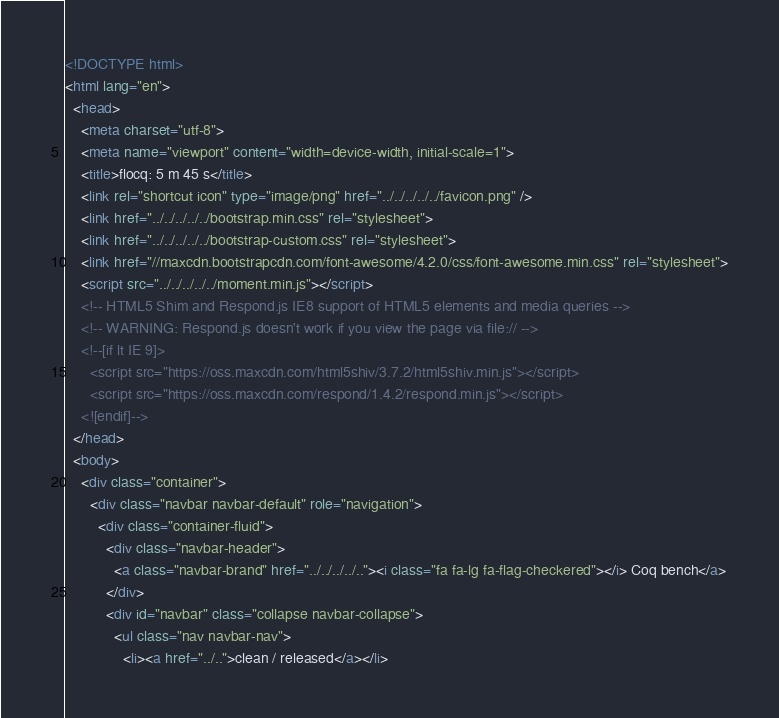<code> <loc_0><loc_0><loc_500><loc_500><_HTML_><!DOCTYPE html>
<html lang="en">
  <head>
    <meta charset="utf-8">
    <meta name="viewport" content="width=device-width, initial-scale=1">
    <title>flocq: 5 m 45 s</title>
    <link rel="shortcut icon" type="image/png" href="../../../../../favicon.png" />
    <link href="../../../../../bootstrap.min.css" rel="stylesheet">
    <link href="../../../../../bootstrap-custom.css" rel="stylesheet">
    <link href="//maxcdn.bootstrapcdn.com/font-awesome/4.2.0/css/font-awesome.min.css" rel="stylesheet">
    <script src="../../../../../moment.min.js"></script>
    <!-- HTML5 Shim and Respond.js IE8 support of HTML5 elements and media queries -->
    <!-- WARNING: Respond.js doesn't work if you view the page via file:// -->
    <!--[if lt IE 9]>
      <script src="https://oss.maxcdn.com/html5shiv/3.7.2/html5shiv.min.js"></script>
      <script src="https://oss.maxcdn.com/respond/1.4.2/respond.min.js"></script>
    <![endif]-->
  </head>
  <body>
    <div class="container">
      <div class="navbar navbar-default" role="navigation">
        <div class="container-fluid">
          <div class="navbar-header">
            <a class="navbar-brand" href="../../../../.."><i class="fa fa-lg fa-flag-checkered"></i> Coq bench</a>
          </div>
          <div id="navbar" class="collapse navbar-collapse">
            <ul class="nav navbar-nav">
              <li><a href="../..">clean / released</a></li></code> 